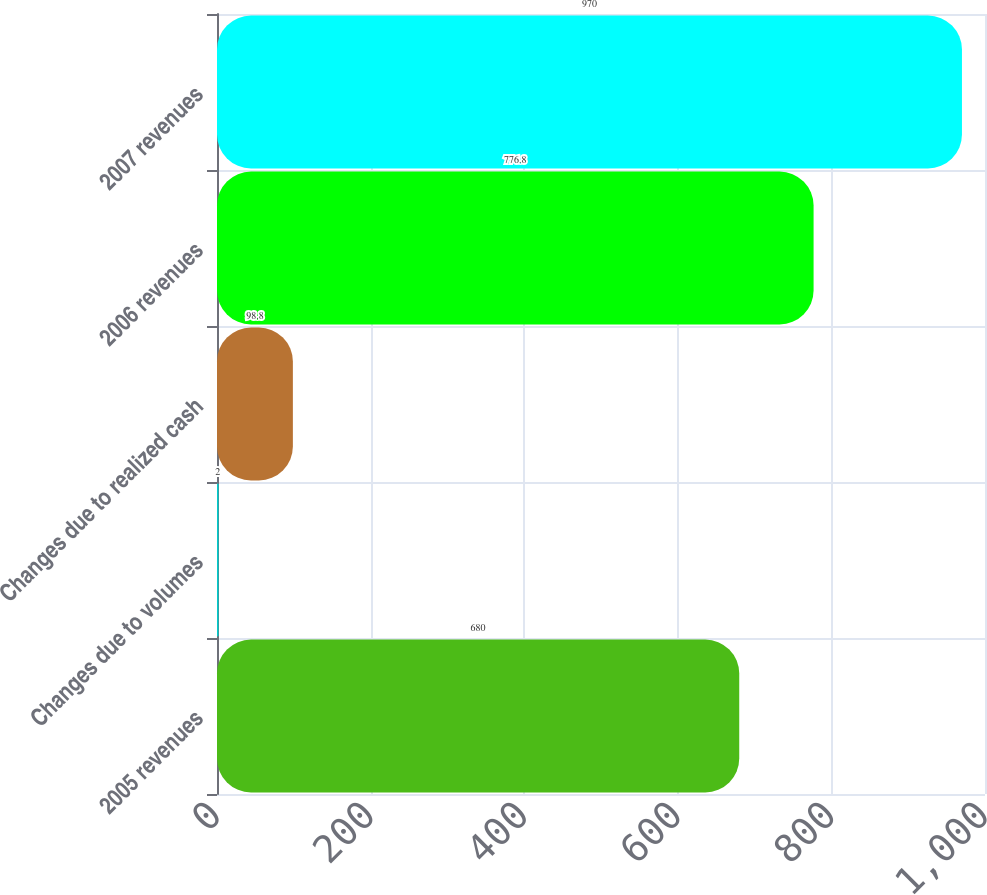Convert chart. <chart><loc_0><loc_0><loc_500><loc_500><bar_chart><fcel>2005 revenues<fcel>Changes due to volumes<fcel>Changes due to realized cash<fcel>2006 revenues<fcel>2007 revenues<nl><fcel>680<fcel>2<fcel>98.8<fcel>776.8<fcel>970<nl></chart> 